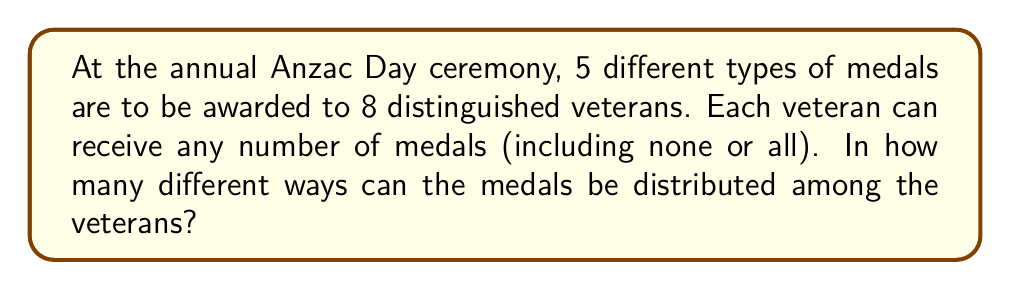Provide a solution to this math problem. Let's approach this step-by-step:

1) This is a problem of distributing distinct objects (medals) into distinct boxes (veterans) where each box can contain any number of objects.

2) For each medal, we have 8 choices of veterans to give it to, plus the choice of not awarding it at all. This means we have 9 choices for each medal.

3) Since there are 5 different types of medals, and each medal's distribution is independent of the others, we can use the multiplication principle.

4) The total number of ways to distribute the medals is therefore:

   $$9 \times 9 \times 9 \times 9 \times 9 = 9^5$$

5) We can calculate this:

   $$9^5 = 9 \times 9 \times 9 \times 9 \times 9 = 59,049$$

Therefore, there are 59,049 different ways to distribute the medals among the veterans.
Answer: $9^5 = 59,049$ 